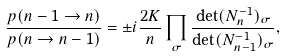<formula> <loc_0><loc_0><loc_500><loc_500>\frac { p ( n - 1 \rightarrow n ) } { p ( n \rightarrow n - 1 ) } = \pm i \frac { 2 K } { n } \prod _ { \sigma } \frac { \det ( N ^ { - 1 } _ { n } ) _ { \sigma } } { \det ( N ^ { - 1 } _ { n - 1 } ) _ { \sigma } } ,</formula> 